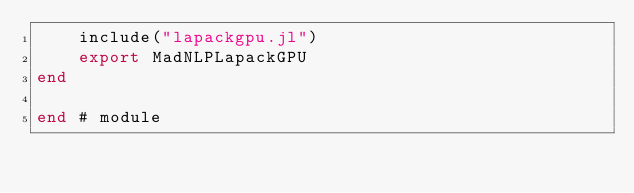Convert code to text. <code><loc_0><loc_0><loc_500><loc_500><_Julia_>    include("lapackgpu.jl")
    export MadNLPLapackGPU
end

end # module
</code> 